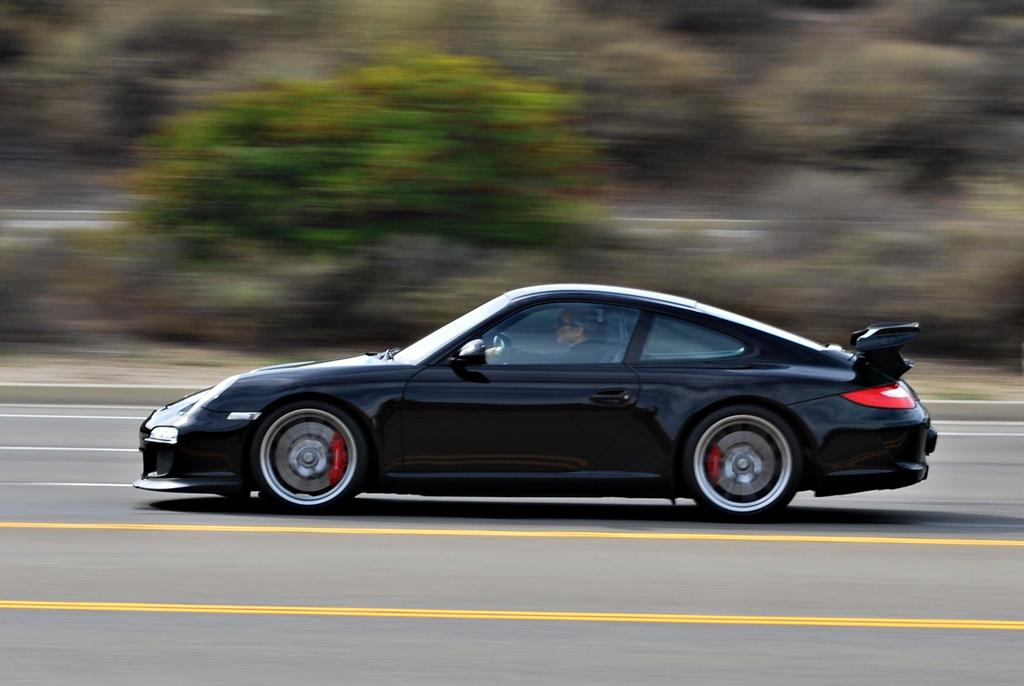What color is the car in the image? The car in the image is black. Who or what is inside the car? A person is sitting in the car. What type of vegetation can be seen in the image? There are trees visible in the image. How would you describe the background of the image? The background of the image is blurred. What type of nerve is being stimulated by the sister in the image? There is no sister present in the image, nor is there any mention of a nerve being stimulated. 